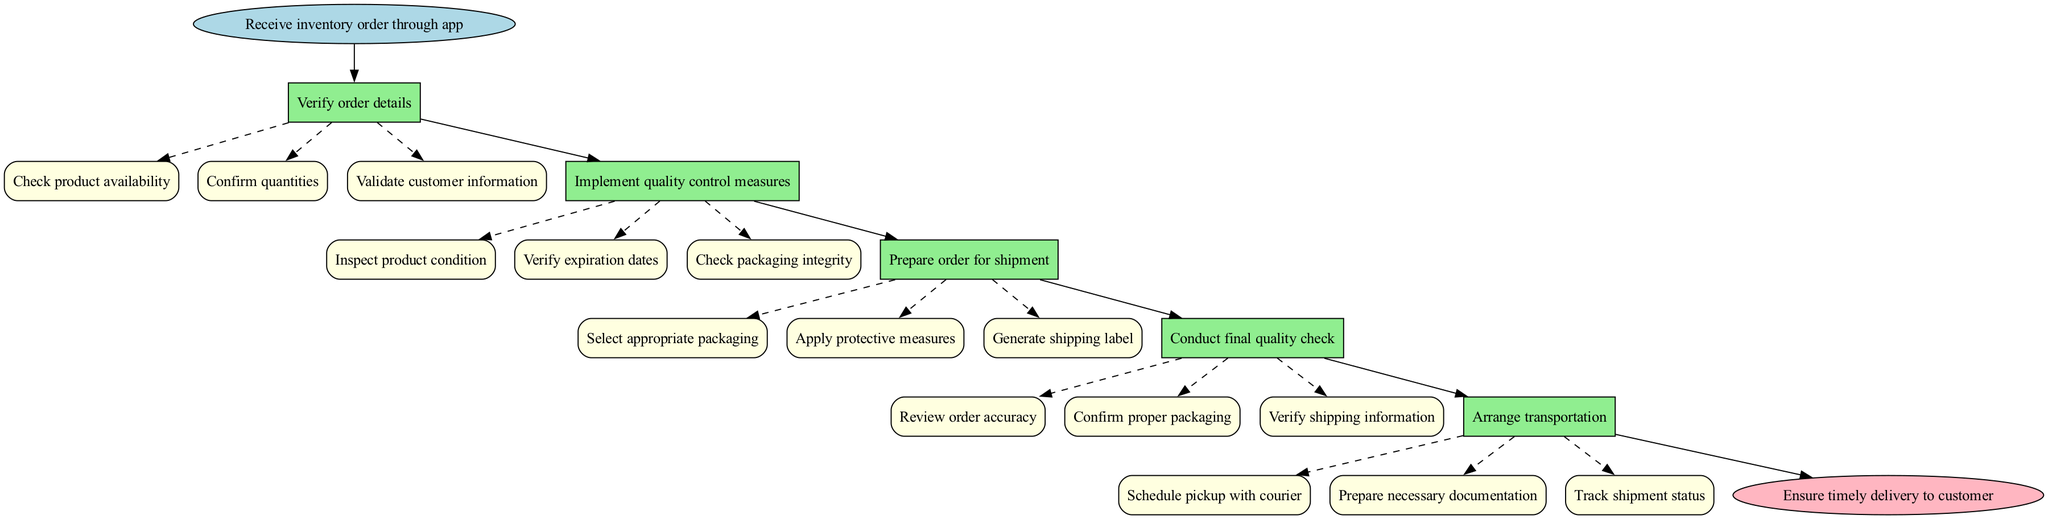What is the starting point of the clinical pathway? The starting point of the clinical pathway is indicated as the first node in the diagram, which states "Receive inventory order through app."
Answer: Receive inventory order through app How many main steps are outlined in the pathway? By counting the distinct steps listed in the diagram, there are five main steps that outline the clinical pathway.
Answer: 5 What is the final outcome of the clinical pathway? The final outcome is shown in the last node of the pathway, which states "Ensure timely delivery to customer."
Answer: Ensure timely delivery to customer What does the first main step involve? The first main step is titled "Verify order details," which details specific actions like checking product availability and confirming quantities.
Answer: Verify order details In which main step is product condition inspected? The inspection of product condition occurs in the second main step titled "Implement quality control measures."
Answer: Implement quality control measures What substep comes after "Select appropriate packaging"? The substep that follows "Select appropriate packaging" in the third main step is "Apply protective measures."
Answer: Apply protective measures What occurs before arranging transportation? Before arranging transportation, a "Conduct final quality check" step takes place, ensuring all order details are accurate and properly packaged.
Answer: Conduct final quality check How many substeps are in the step "Arrange transportation"? The "Arrange transportation" step contains three substeps, which includes scheduling pickups and preparing documentation.
Answer: 3 What is the relationship between "Verify order details" and "Implement quality control measures"? The relationship shows that "Implement quality control measures" follows after "Verify order details," indicating a sequential flow in the clinical pathway.
Answer: Sequential flow 